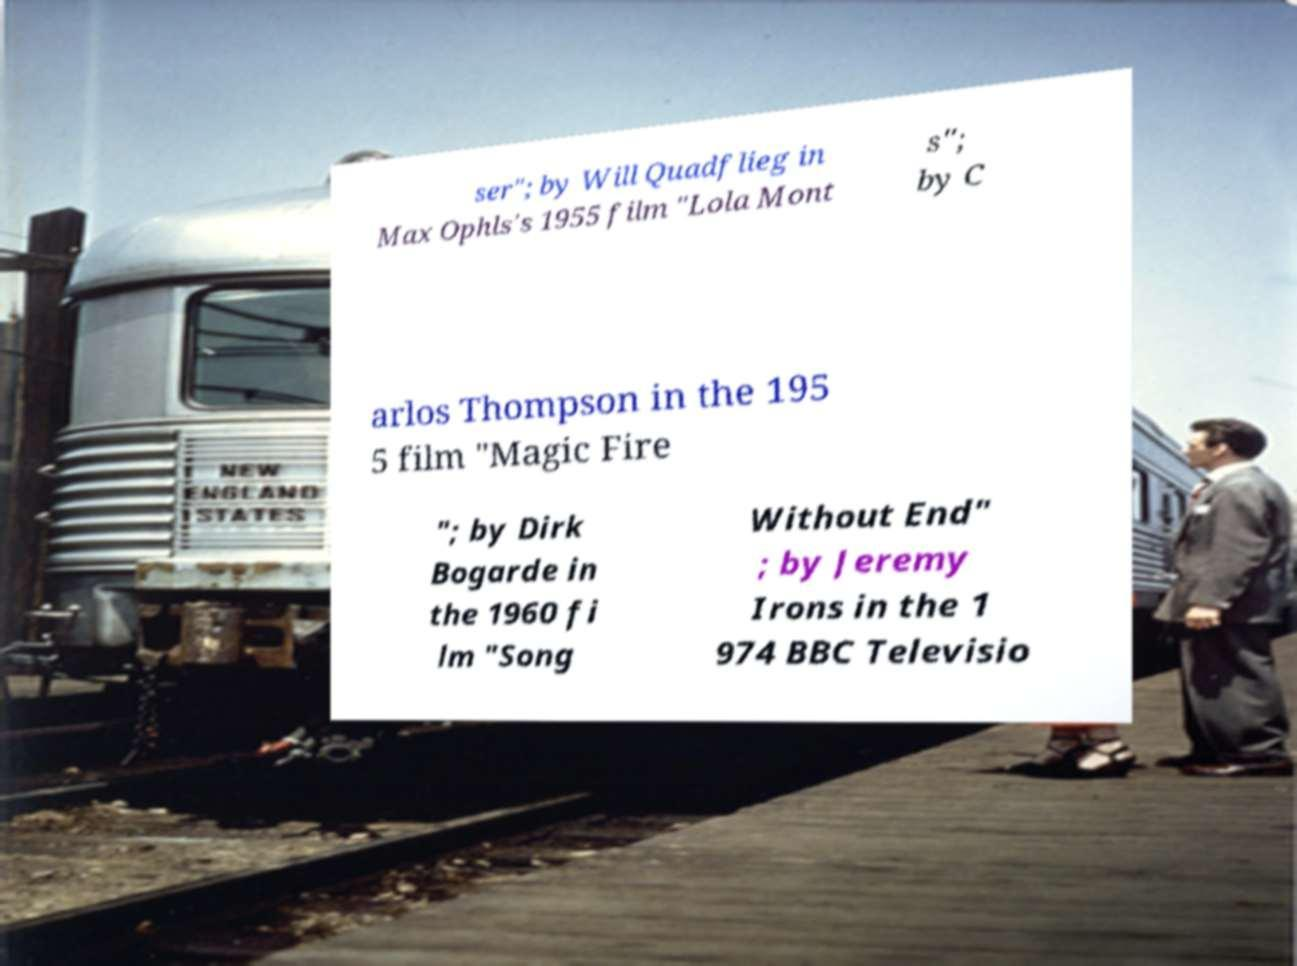There's text embedded in this image that I need extracted. Can you transcribe it verbatim? ser"; by Will Quadflieg in Max Ophls's 1955 film "Lola Mont s"; by C arlos Thompson in the 195 5 film "Magic Fire "; by Dirk Bogarde in the 1960 fi lm "Song Without End" ; by Jeremy Irons in the 1 974 BBC Televisio 